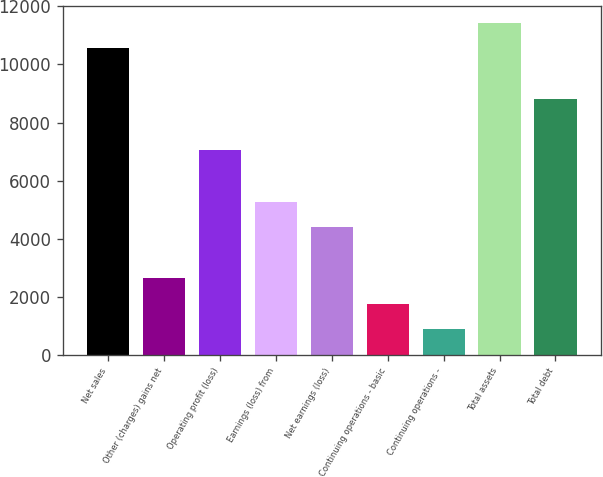Convert chart to OTSL. <chart><loc_0><loc_0><loc_500><loc_500><bar_chart><fcel>Net sales<fcel>Other (charges) gains net<fcel>Operating profit (loss)<fcel>Earnings (loss) from<fcel>Net earnings (loss)<fcel>Continuing operations - basic<fcel>Continuing operations -<fcel>Total assets<fcel>Total debt<nl><fcel>10555<fcel>2639.46<fcel>7037.01<fcel>5277.99<fcel>4398.48<fcel>1759.95<fcel>880.44<fcel>11434.6<fcel>8796.03<nl></chart> 